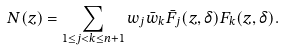<formula> <loc_0><loc_0><loc_500><loc_500>N ( z ) = \sum _ { 1 \leq j < k \leq n + 1 } w _ { j } \bar { w } _ { k } \bar { F } _ { j } ( z , \delta ) F _ { k } ( z , \delta ) .</formula> 